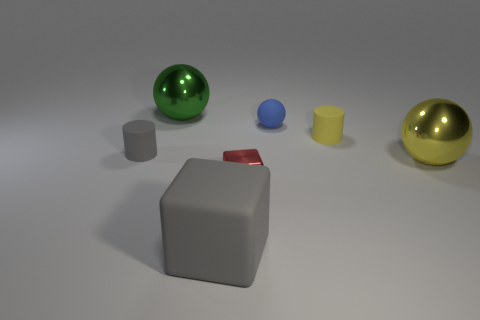There is a cylinder that is the same color as the big rubber cube; what is its size?
Your answer should be very brief. Small. What number of things are in front of the large thing to the right of the gray block?
Offer a very short reply. 2. How many blue objects are shiny spheres or small matte things?
Provide a succinct answer. 1. There is a tiny thing in front of the big shiny sphere right of the small cylinder on the right side of the small blue matte ball; what shape is it?
Offer a very short reply. Cube. There is a block that is the same size as the matte ball; what color is it?
Make the answer very short. Red. How many yellow objects are the same shape as the small gray object?
Your answer should be very brief. 1. There is a blue matte object; is it the same size as the matte thing that is in front of the big yellow ball?
Your response must be concise. No. The large thing that is in front of the big sphere that is right of the big green object is what shape?
Provide a succinct answer. Cube. Is the number of tiny red metallic things that are behind the green ball less than the number of objects?
Offer a very short reply. Yes. What is the shape of the small matte thing that is the same color as the matte cube?
Offer a terse response. Cylinder. 